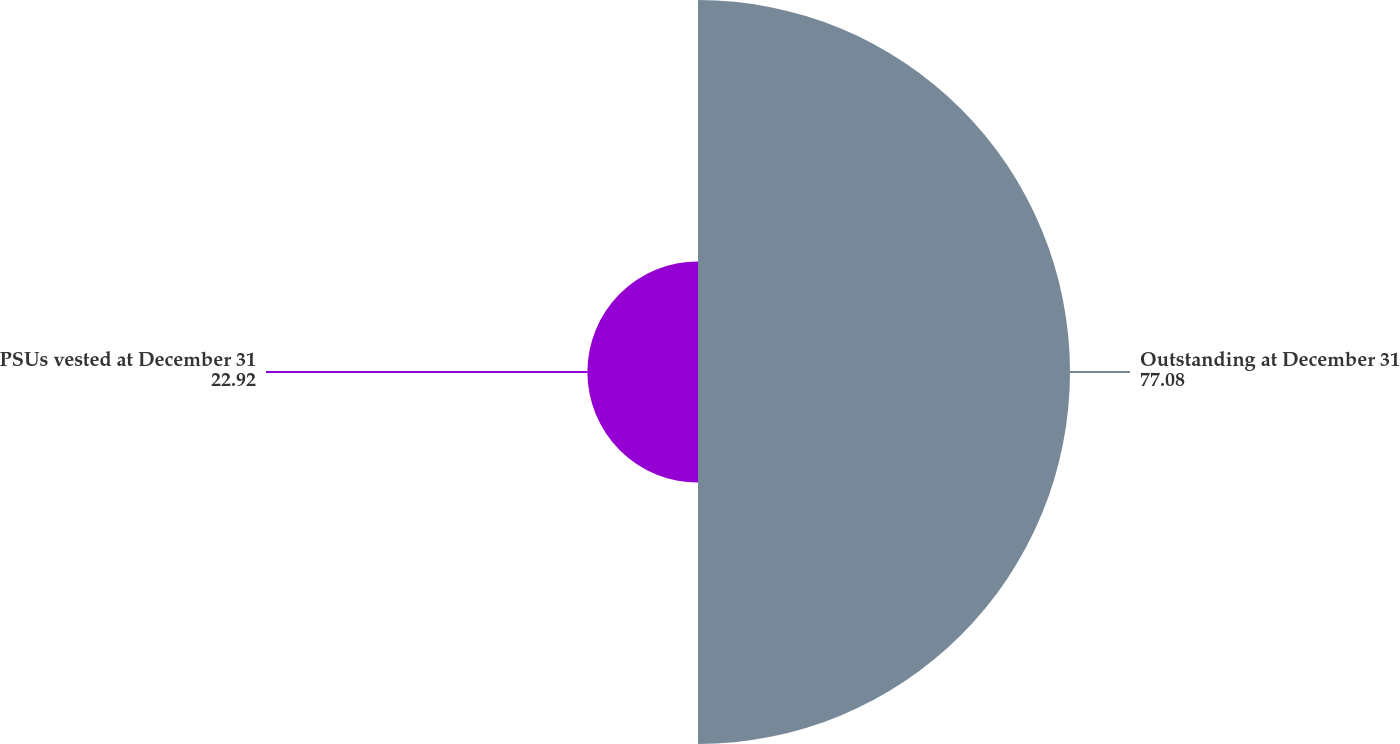<chart> <loc_0><loc_0><loc_500><loc_500><pie_chart><fcel>Outstanding at December 31<fcel>PSUs vested at December 31<nl><fcel>77.08%<fcel>22.92%<nl></chart> 